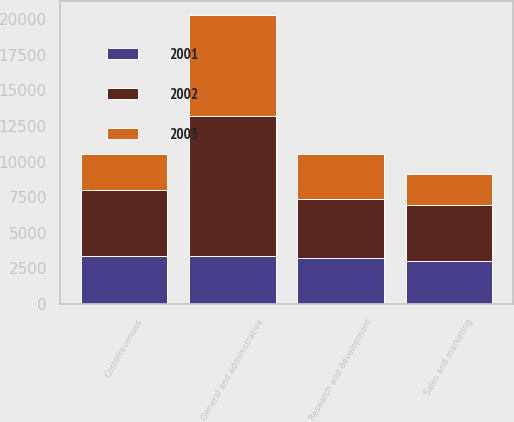<chart> <loc_0><loc_0><loc_500><loc_500><stacked_bar_chart><ecel><fcel>Costofrevenues<fcel>Sales and marketing<fcel>General and administrative<fcel>Research and development<nl><fcel>2003<fcel>2560<fcel>2202<fcel>7107<fcel>3162<nl><fcel>2001<fcel>3399<fcel>3002<fcel>3399<fcel>3221<nl><fcel>2002<fcel>4602<fcel>3920<fcel>9763<fcel>4148<nl></chart> 